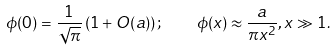<formula> <loc_0><loc_0><loc_500><loc_500>\phi ( 0 ) = \frac { 1 } { \sqrt { \pi } } \left ( 1 + O ( a ) \right ) ; \quad \phi ( x ) \approx \frac { a } { \pi x ^ { 2 } } , x \gg 1 .</formula> 